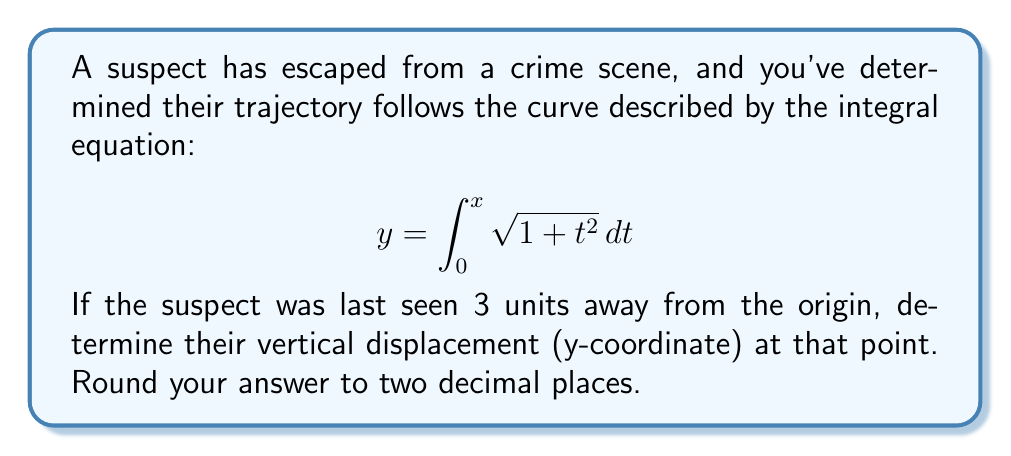Teach me how to tackle this problem. Let's approach this step-by-step:

1) The integral equation given is:
   $$ y = \int_0^x \sqrt{1 + t^2} dt $$

2) This is a definite integral from 0 to x. We need to find y when x = 3.

3) Unfortunately, this integral doesn't have an elementary antiderivative. It's actually the formula for the arc length of a parabola, which results in an elliptic integral.

4) In such cases, we need to use numerical methods. Let's use Simpson's Rule with 6 subintervals for a good approximation.

5) Simpson's Rule formula:
   $$ \int_a^b f(x)dx \approx \frac{h}{3}[f(x_0) + 4f(x_1) + 2f(x_2) + 4f(x_3) + 2f(x_4) + 4f(x_5) + f(x_6)] $$
   where $h = \frac{b-a}{6}$ and $x_i = a + ih$

6) In our case, $a=0$, $b=3$, so $h = \frac{3-0}{6} = 0.5$

7) Let's calculate the values:
   $f(x_0) = \sqrt{1 + 0^2} = 1$
   $f(x_1) = \sqrt{1 + 0.5^2} = 1.118034$
   $f(x_2) = \sqrt{1 + 1^2} = 1.414214$
   $f(x_3) = \sqrt{1 + 1.5^2} = 1.802776$
   $f(x_4) = \sqrt{1 + 2^2} = 2.236068$
   $f(x_5) = \sqrt{1 + 2.5^2} = 2.692582$
   $f(x_6) = \sqrt{1 + 3^2} = 3.162278$

8) Applying Simpson's Rule:
   $y \approx \frac{0.5}{3}[1 + 4(1.118034) + 2(1.414214) + 4(1.802776) + 2(2.236068) + 4(2.692582) + 3.162278]$

9) Calculating this gives us approximately 3.6219.

10) Rounding to two decimal places: 3.62
Answer: 3.62 